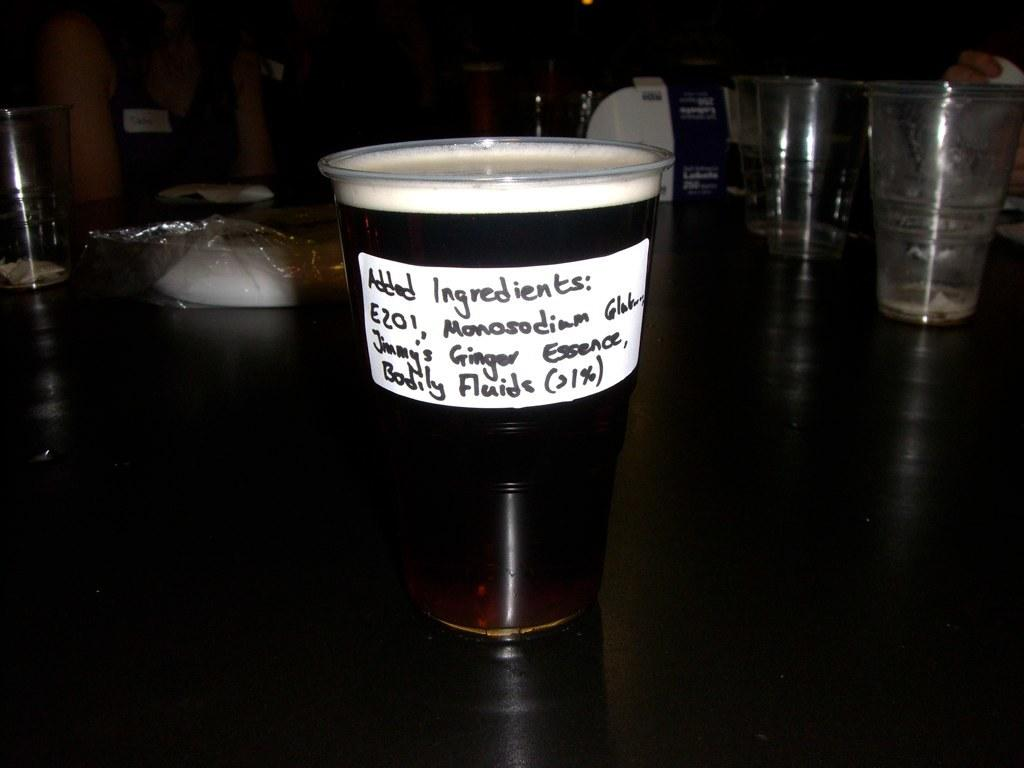<image>
Relay a brief, clear account of the picture shown. Someone took a cup of beer and added ingredients to it. 